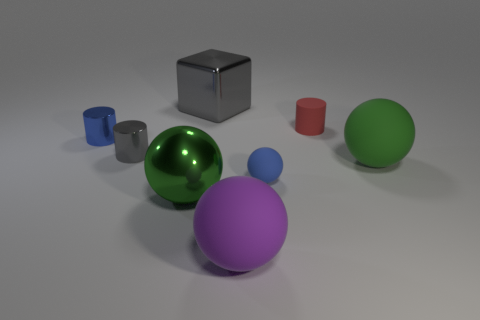There is a gray thing right of the large metal thing in front of the rubber cylinder; what is its shape?
Provide a succinct answer. Cube. How many other things are there of the same shape as the red object?
Your answer should be compact. 2. How big is the matte object behind the big ball behind the small blue matte thing?
Offer a terse response. Small. Are there any large matte balls?
Give a very brief answer. Yes. There is a matte sphere that is behind the tiny blue sphere; how many green objects are in front of it?
Your response must be concise. 1. What is the shape of the object that is in front of the metallic sphere?
Offer a terse response. Sphere. What material is the large gray cube behind the blue object that is right of the gray shiny thing right of the green metal object?
Give a very brief answer. Metal. How many other objects are there of the same size as the gray block?
Ensure brevity in your answer.  3. There is a gray thing that is the same shape as the red thing; what material is it?
Offer a very short reply. Metal. The metal cube has what color?
Your answer should be compact. Gray. 